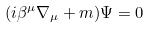<formula> <loc_0><loc_0><loc_500><loc_500>( i \beta ^ { \mu } \nabla _ { \mu } + m ) \Psi = 0</formula> 